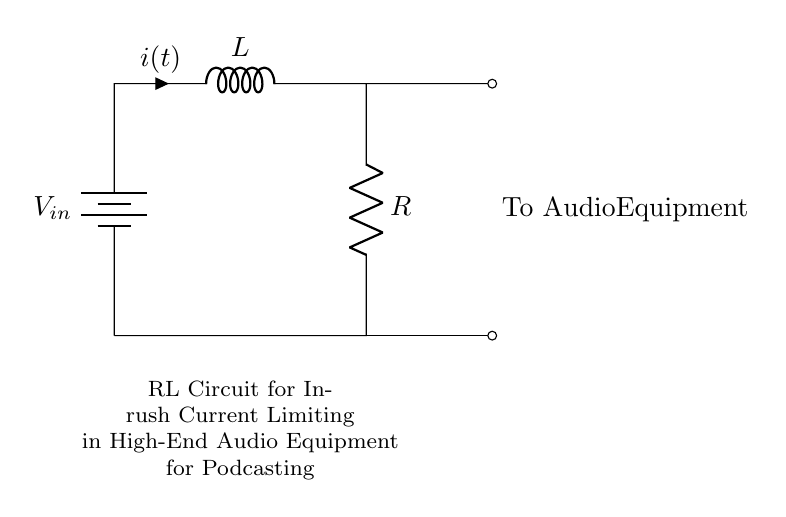What is the main function of the circuit? The circuit is designed for inrush current limiting in audio equipment, helping to protect sensitive components from high startup currents.
Answer: Inrush current limiting What components are present in the circuit? The circuit contains a resistor and an inductor connected in series with a battery, which provides the input voltage.
Answer: Resistor and inductor What does the symbol "V_in" represent in the circuit? "V_in" denotes the input voltage provided by the battery, which powers the circuit.
Answer: Input voltage How does current flow through this circuit? Current flows from the positive terminal of the battery, through the inductor and resistor, and returns to the battery's negative terminal, creating a closed loop.
Answer: Closed loop What is the purpose of the resistor in the RL circuit? The resistor limits the current flowing through the circuit during startup, preventing excessive current from damaging the audio equipment.
Answer: Current limiting Why is an inductor used in this circuit? The inductor stores energy in the magnetic field when current flows, which helps to slow down the rate of current increase, further protecting the audio components from inrush current.
Answer: Energy storage What type of circuit is depicted here? This is an RL circuit, which specifically combines a resistor and an inductor to manage current flow characteristics during startup.
Answer: RL circuit 